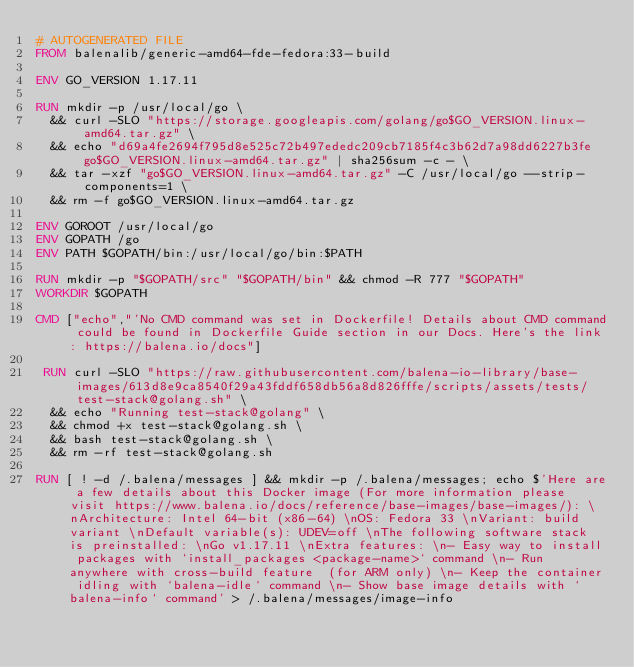Convert code to text. <code><loc_0><loc_0><loc_500><loc_500><_Dockerfile_># AUTOGENERATED FILE
FROM balenalib/generic-amd64-fde-fedora:33-build

ENV GO_VERSION 1.17.11

RUN mkdir -p /usr/local/go \
	&& curl -SLO "https://storage.googleapis.com/golang/go$GO_VERSION.linux-amd64.tar.gz" \
	&& echo "d69a4fe2694f795d8e525c72b497ededc209cb7185f4c3b62d7a98dd6227b3fe  go$GO_VERSION.linux-amd64.tar.gz" | sha256sum -c - \
	&& tar -xzf "go$GO_VERSION.linux-amd64.tar.gz" -C /usr/local/go --strip-components=1 \
	&& rm -f go$GO_VERSION.linux-amd64.tar.gz

ENV GOROOT /usr/local/go
ENV GOPATH /go
ENV PATH $GOPATH/bin:/usr/local/go/bin:$PATH

RUN mkdir -p "$GOPATH/src" "$GOPATH/bin" && chmod -R 777 "$GOPATH"
WORKDIR $GOPATH

CMD ["echo","'No CMD command was set in Dockerfile! Details about CMD command could be found in Dockerfile Guide section in our Docs. Here's the link: https://balena.io/docs"]

 RUN curl -SLO "https://raw.githubusercontent.com/balena-io-library/base-images/613d8e9ca8540f29a43fddf658db56a8d826fffe/scripts/assets/tests/test-stack@golang.sh" \
  && echo "Running test-stack@golang" \
  && chmod +x test-stack@golang.sh \
  && bash test-stack@golang.sh \
  && rm -rf test-stack@golang.sh 

RUN [ ! -d /.balena/messages ] && mkdir -p /.balena/messages; echo $'Here are a few details about this Docker image (For more information please visit https://www.balena.io/docs/reference/base-images/base-images/): \nArchitecture: Intel 64-bit (x86-64) \nOS: Fedora 33 \nVariant: build variant \nDefault variable(s): UDEV=off \nThe following software stack is preinstalled: \nGo v1.17.11 \nExtra features: \n- Easy way to install packages with `install_packages <package-name>` command \n- Run anywhere with cross-build feature  (for ARM only) \n- Keep the container idling with `balena-idle` command \n- Show base image details with `balena-info` command' > /.balena/messages/image-info</code> 